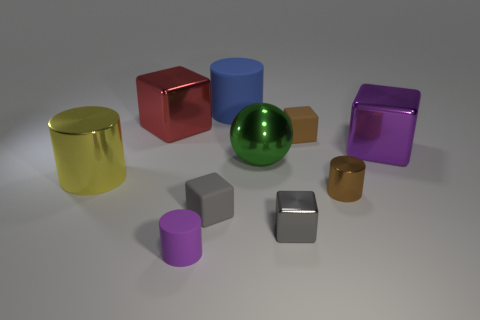Subtract all tiny brown cylinders. How many cylinders are left? 3 Subtract all green cylinders. How many gray cubes are left? 2 Subtract all brown cylinders. How many cylinders are left? 3 Subtract 1 blocks. How many blocks are left? 4 Subtract all yellow cubes. Subtract all gray balls. How many cubes are left? 5 Subtract 0 brown spheres. How many objects are left? 10 Subtract all balls. How many objects are left? 9 Subtract all tiny purple things. Subtract all big rubber things. How many objects are left? 8 Add 6 small brown matte things. How many small brown matte things are left? 7 Add 4 large metallic balls. How many large metallic balls exist? 5 